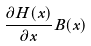Convert formula to latex. <formula><loc_0><loc_0><loc_500><loc_500>\frac { \partial H ( x ) } { \partial x } B ( x )</formula> 